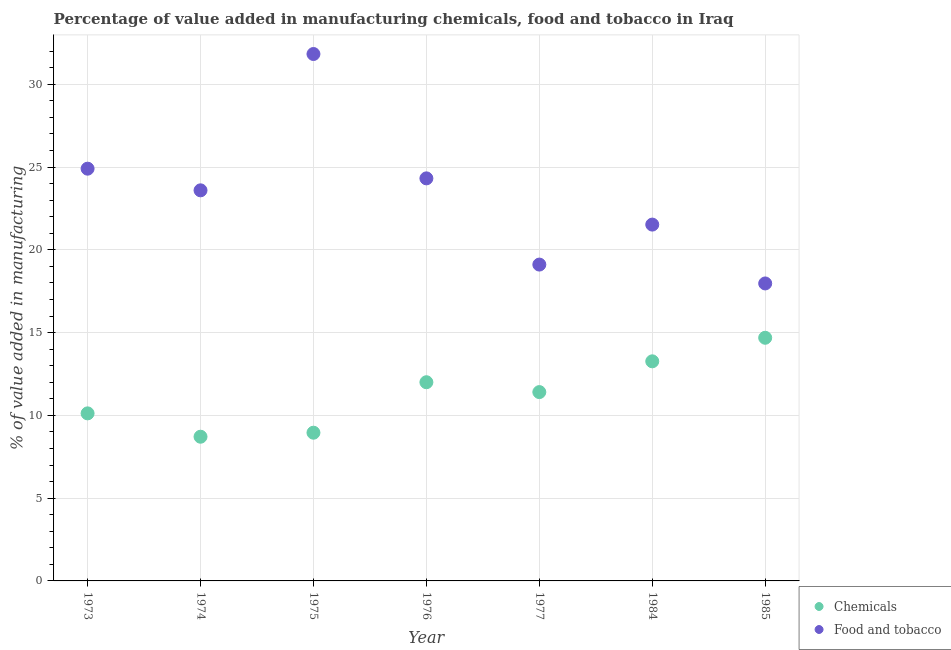Is the number of dotlines equal to the number of legend labels?
Provide a short and direct response. Yes. What is the value added by  manufacturing chemicals in 1974?
Provide a short and direct response. 8.71. Across all years, what is the maximum value added by  manufacturing chemicals?
Provide a short and direct response. 14.69. Across all years, what is the minimum value added by  manufacturing chemicals?
Ensure brevity in your answer.  8.71. In which year was the value added by manufacturing food and tobacco maximum?
Your answer should be compact. 1975. In which year was the value added by manufacturing food and tobacco minimum?
Keep it short and to the point. 1985. What is the total value added by  manufacturing chemicals in the graph?
Ensure brevity in your answer.  79.15. What is the difference between the value added by  manufacturing chemicals in 1974 and that in 1984?
Offer a terse response. -4.56. What is the difference between the value added by manufacturing food and tobacco in 1975 and the value added by  manufacturing chemicals in 1974?
Offer a terse response. 23.12. What is the average value added by  manufacturing chemicals per year?
Provide a short and direct response. 11.31. In the year 1974, what is the difference between the value added by manufacturing food and tobacco and value added by  manufacturing chemicals?
Your answer should be very brief. 14.89. In how many years, is the value added by  manufacturing chemicals greater than 1 %?
Your answer should be very brief. 7. What is the ratio of the value added by manufacturing food and tobacco in 1973 to that in 1975?
Provide a short and direct response. 0.78. What is the difference between the highest and the second highest value added by  manufacturing chemicals?
Ensure brevity in your answer.  1.42. What is the difference between the highest and the lowest value added by manufacturing food and tobacco?
Ensure brevity in your answer.  13.86. In how many years, is the value added by manufacturing food and tobacco greater than the average value added by manufacturing food and tobacco taken over all years?
Ensure brevity in your answer.  4. Does the value added by  manufacturing chemicals monotonically increase over the years?
Your answer should be very brief. No. How many dotlines are there?
Offer a very short reply. 2. Are the values on the major ticks of Y-axis written in scientific E-notation?
Your answer should be compact. No. Does the graph contain grids?
Offer a very short reply. Yes. Where does the legend appear in the graph?
Your response must be concise. Bottom right. How many legend labels are there?
Your response must be concise. 2. What is the title of the graph?
Offer a very short reply. Percentage of value added in manufacturing chemicals, food and tobacco in Iraq. What is the label or title of the X-axis?
Your answer should be very brief. Year. What is the label or title of the Y-axis?
Ensure brevity in your answer.  % of value added in manufacturing. What is the % of value added in manufacturing of Chemicals in 1973?
Ensure brevity in your answer.  10.12. What is the % of value added in manufacturing of Food and tobacco in 1973?
Your answer should be compact. 24.9. What is the % of value added in manufacturing of Chemicals in 1974?
Give a very brief answer. 8.71. What is the % of value added in manufacturing in Food and tobacco in 1974?
Offer a terse response. 23.6. What is the % of value added in manufacturing in Chemicals in 1975?
Give a very brief answer. 8.95. What is the % of value added in manufacturing in Food and tobacco in 1975?
Make the answer very short. 31.83. What is the % of value added in manufacturing in Chemicals in 1976?
Provide a short and direct response. 12. What is the % of value added in manufacturing in Food and tobacco in 1976?
Offer a terse response. 24.32. What is the % of value added in manufacturing of Chemicals in 1977?
Offer a terse response. 11.41. What is the % of value added in manufacturing in Food and tobacco in 1977?
Your answer should be compact. 19.11. What is the % of value added in manufacturing of Chemicals in 1984?
Ensure brevity in your answer.  13.27. What is the % of value added in manufacturing in Food and tobacco in 1984?
Your answer should be compact. 21.53. What is the % of value added in manufacturing of Chemicals in 1985?
Ensure brevity in your answer.  14.69. What is the % of value added in manufacturing of Food and tobacco in 1985?
Your answer should be very brief. 17.97. Across all years, what is the maximum % of value added in manufacturing of Chemicals?
Your answer should be compact. 14.69. Across all years, what is the maximum % of value added in manufacturing in Food and tobacco?
Keep it short and to the point. 31.83. Across all years, what is the minimum % of value added in manufacturing in Chemicals?
Offer a very short reply. 8.71. Across all years, what is the minimum % of value added in manufacturing of Food and tobacco?
Make the answer very short. 17.97. What is the total % of value added in manufacturing in Chemicals in the graph?
Offer a very short reply. 79.15. What is the total % of value added in manufacturing in Food and tobacco in the graph?
Offer a terse response. 163.26. What is the difference between the % of value added in manufacturing of Chemicals in 1973 and that in 1974?
Offer a very short reply. 1.41. What is the difference between the % of value added in manufacturing in Food and tobacco in 1973 and that in 1974?
Offer a very short reply. 1.31. What is the difference between the % of value added in manufacturing in Chemicals in 1973 and that in 1975?
Offer a very short reply. 1.17. What is the difference between the % of value added in manufacturing in Food and tobacco in 1973 and that in 1975?
Keep it short and to the point. -6.93. What is the difference between the % of value added in manufacturing in Chemicals in 1973 and that in 1976?
Make the answer very short. -1.88. What is the difference between the % of value added in manufacturing of Food and tobacco in 1973 and that in 1976?
Your response must be concise. 0.59. What is the difference between the % of value added in manufacturing of Chemicals in 1973 and that in 1977?
Your response must be concise. -1.29. What is the difference between the % of value added in manufacturing of Food and tobacco in 1973 and that in 1977?
Provide a short and direct response. 5.79. What is the difference between the % of value added in manufacturing of Chemicals in 1973 and that in 1984?
Provide a short and direct response. -3.14. What is the difference between the % of value added in manufacturing of Food and tobacco in 1973 and that in 1984?
Offer a very short reply. 3.38. What is the difference between the % of value added in manufacturing in Chemicals in 1973 and that in 1985?
Ensure brevity in your answer.  -4.57. What is the difference between the % of value added in manufacturing of Food and tobacco in 1973 and that in 1985?
Make the answer very short. 6.93. What is the difference between the % of value added in manufacturing of Chemicals in 1974 and that in 1975?
Provide a succinct answer. -0.24. What is the difference between the % of value added in manufacturing in Food and tobacco in 1974 and that in 1975?
Your answer should be very brief. -8.24. What is the difference between the % of value added in manufacturing in Chemicals in 1974 and that in 1976?
Provide a short and direct response. -3.29. What is the difference between the % of value added in manufacturing of Food and tobacco in 1974 and that in 1976?
Provide a succinct answer. -0.72. What is the difference between the % of value added in manufacturing in Chemicals in 1974 and that in 1977?
Offer a terse response. -2.7. What is the difference between the % of value added in manufacturing in Food and tobacco in 1974 and that in 1977?
Your answer should be very brief. 4.49. What is the difference between the % of value added in manufacturing in Chemicals in 1974 and that in 1984?
Offer a terse response. -4.55. What is the difference between the % of value added in manufacturing of Food and tobacco in 1974 and that in 1984?
Your answer should be very brief. 2.07. What is the difference between the % of value added in manufacturing in Chemicals in 1974 and that in 1985?
Give a very brief answer. -5.98. What is the difference between the % of value added in manufacturing of Food and tobacco in 1974 and that in 1985?
Your answer should be very brief. 5.63. What is the difference between the % of value added in manufacturing of Chemicals in 1975 and that in 1976?
Provide a short and direct response. -3.05. What is the difference between the % of value added in manufacturing in Food and tobacco in 1975 and that in 1976?
Offer a terse response. 7.51. What is the difference between the % of value added in manufacturing in Chemicals in 1975 and that in 1977?
Your answer should be compact. -2.45. What is the difference between the % of value added in manufacturing in Food and tobacco in 1975 and that in 1977?
Provide a short and direct response. 12.72. What is the difference between the % of value added in manufacturing in Chemicals in 1975 and that in 1984?
Keep it short and to the point. -4.31. What is the difference between the % of value added in manufacturing in Food and tobacco in 1975 and that in 1984?
Make the answer very short. 10.31. What is the difference between the % of value added in manufacturing in Chemicals in 1975 and that in 1985?
Your answer should be compact. -5.74. What is the difference between the % of value added in manufacturing in Food and tobacco in 1975 and that in 1985?
Your response must be concise. 13.86. What is the difference between the % of value added in manufacturing in Chemicals in 1976 and that in 1977?
Give a very brief answer. 0.6. What is the difference between the % of value added in manufacturing in Food and tobacco in 1976 and that in 1977?
Give a very brief answer. 5.21. What is the difference between the % of value added in manufacturing in Chemicals in 1976 and that in 1984?
Provide a succinct answer. -1.26. What is the difference between the % of value added in manufacturing in Food and tobacco in 1976 and that in 1984?
Ensure brevity in your answer.  2.79. What is the difference between the % of value added in manufacturing of Chemicals in 1976 and that in 1985?
Keep it short and to the point. -2.69. What is the difference between the % of value added in manufacturing of Food and tobacco in 1976 and that in 1985?
Make the answer very short. 6.35. What is the difference between the % of value added in manufacturing in Chemicals in 1977 and that in 1984?
Your response must be concise. -1.86. What is the difference between the % of value added in manufacturing in Food and tobacco in 1977 and that in 1984?
Offer a very short reply. -2.42. What is the difference between the % of value added in manufacturing of Chemicals in 1977 and that in 1985?
Your response must be concise. -3.28. What is the difference between the % of value added in manufacturing in Food and tobacco in 1977 and that in 1985?
Your answer should be very brief. 1.14. What is the difference between the % of value added in manufacturing in Chemicals in 1984 and that in 1985?
Offer a terse response. -1.42. What is the difference between the % of value added in manufacturing in Food and tobacco in 1984 and that in 1985?
Keep it short and to the point. 3.56. What is the difference between the % of value added in manufacturing of Chemicals in 1973 and the % of value added in manufacturing of Food and tobacco in 1974?
Make the answer very short. -13.47. What is the difference between the % of value added in manufacturing in Chemicals in 1973 and the % of value added in manufacturing in Food and tobacco in 1975?
Your answer should be very brief. -21.71. What is the difference between the % of value added in manufacturing of Chemicals in 1973 and the % of value added in manufacturing of Food and tobacco in 1976?
Provide a succinct answer. -14.2. What is the difference between the % of value added in manufacturing in Chemicals in 1973 and the % of value added in manufacturing in Food and tobacco in 1977?
Give a very brief answer. -8.99. What is the difference between the % of value added in manufacturing of Chemicals in 1973 and the % of value added in manufacturing of Food and tobacco in 1984?
Your response must be concise. -11.4. What is the difference between the % of value added in manufacturing in Chemicals in 1973 and the % of value added in manufacturing in Food and tobacco in 1985?
Make the answer very short. -7.85. What is the difference between the % of value added in manufacturing of Chemicals in 1974 and the % of value added in manufacturing of Food and tobacco in 1975?
Your answer should be compact. -23.12. What is the difference between the % of value added in manufacturing of Chemicals in 1974 and the % of value added in manufacturing of Food and tobacco in 1976?
Offer a terse response. -15.61. What is the difference between the % of value added in manufacturing in Chemicals in 1974 and the % of value added in manufacturing in Food and tobacco in 1977?
Ensure brevity in your answer.  -10.4. What is the difference between the % of value added in manufacturing of Chemicals in 1974 and the % of value added in manufacturing of Food and tobacco in 1984?
Offer a very short reply. -12.82. What is the difference between the % of value added in manufacturing in Chemicals in 1974 and the % of value added in manufacturing in Food and tobacco in 1985?
Your answer should be compact. -9.26. What is the difference between the % of value added in manufacturing of Chemicals in 1975 and the % of value added in manufacturing of Food and tobacco in 1976?
Ensure brevity in your answer.  -15.37. What is the difference between the % of value added in manufacturing of Chemicals in 1975 and the % of value added in manufacturing of Food and tobacco in 1977?
Ensure brevity in your answer.  -10.16. What is the difference between the % of value added in manufacturing of Chemicals in 1975 and the % of value added in manufacturing of Food and tobacco in 1984?
Offer a terse response. -12.57. What is the difference between the % of value added in manufacturing in Chemicals in 1975 and the % of value added in manufacturing in Food and tobacco in 1985?
Your response must be concise. -9.02. What is the difference between the % of value added in manufacturing of Chemicals in 1976 and the % of value added in manufacturing of Food and tobacco in 1977?
Ensure brevity in your answer.  -7.11. What is the difference between the % of value added in manufacturing in Chemicals in 1976 and the % of value added in manufacturing in Food and tobacco in 1984?
Make the answer very short. -9.52. What is the difference between the % of value added in manufacturing in Chemicals in 1976 and the % of value added in manufacturing in Food and tobacco in 1985?
Your answer should be very brief. -5.97. What is the difference between the % of value added in manufacturing in Chemicals in 1977 and the % of value added in manufacturing in Food and tobacco in 1984?
Your answer should be compact. -10.12. What is the difference between the % of value added in manufacturing of Chemicals in 1977 and the % of value added in manufacturing of Food and tobacco in 1985?
Offer a very short reply. -6.56. What is the difference between the % of value added in manufacturing in Chemicals in 1984 and the % of value added in manufacturing in Food and tobacco in 1985?
Provide a short and direct response. -4.71. What is the average % of value added in manufacturing of Chemicals per year?
Your answer should be compact. 11.31. What is the average % of value added in manufacturing of Food and tobacco per year?
Offer a very short reply. 23.32. In the year 1973, what is the difference between the % of value added in manufacturing in Chemicals and % of value added in manufacturing in Food and tobacco?
Ensure brevity in your answer.  -14.78. In the year 1974, what is the difference between the % of value added in manufacturing of Chemicals and % of value added in manufacturing of Food and tobacco?
Your answer should be compact. -14.89. In the year 1975, what is the difference between the % of value added in manufacturing in Chemicals and % of value added in manufacturing in Food and tobacco?
Give a very brief answer. -22.88. In the year 1976, what is the difference between the % of value added in manufacturing in Chemicals and % of value added in manufacturing in Food and tobacco?
Offer a very short reply. -12.32. In the year 1977, what is the difference between the % of value added in manufacturing in Chemicals and % of value added in manufacturing in Food and tobacco?
Make the answer very short. -7.7. In the year 1984, what is the difference between the % of value added in manufacturing of Chemicals and % of value added in manufacturing of Food and tobacco?
Provide a short and direct response. -8.26. In the year 1985, what is the difference between the % of value added in manufacturing of Chemicals and % of value added in manufacturing of Food and tobacco?
Offer a very short reply. -3.28. What is the ratio of the % of value added in manufacturing in Chemicals in 1973 to that in 1974?
Provide a succinct answer. 1.16. What is the ratio of the % of value added in manufacturing in Food and tobacco in 1973 to that in 1974?
Make the answer very short. 1.06. What is the ratio of the % of value added in manufacturing of Chemicals in 1973 to that in 1975?
Ensure brevity in your answer.  1.13. What is the ratio of the % of value added in manufacturing of Food and tobacco in 1973 to that in 1975?
Ensure brevity in your answer.  0.78. What is the ratio of the % of value added in manufacturing in Chemicals in 1973 to that in 1976?
Ensure brevity in your answer.  0.84. What is the ratio of the % of value added in manufacturing of Food and tobacco in 1973 to that in 1976?
Your response must be concise. 1.02. What is the ratio of the % of value added in manufacturing of Chemicals in 1973 to that in 1977?
Offer a terse response. 0.89. What is the ratio of the % of value added in manufacturing of Food and tobacco in 1973 to that in 1977?
Give a very brief answer. 1.3. What is the ratio of the % of value added in manufacturing in Chemicals in 1973 to that in 1984?
Your answer should be very brief. 0.76. What is the ratio of the % of value added in manufacturing in Food and tobacco in 1973 to that in 1984?
Your response must be concise. 1.16. What is the ratio of the % of value added in manufacturing of Chemicals in 1973 to that in 1985?
Your answer should be very brief. 0.69. What is the ratio of the % of value added in manufacturing in Food and tobacco in 1973 to that in 1985?
Your answer should be very brief. 1.39. What is the ratio of the % of value added in manufacturing of Chemicals in 1974 to that in 1975?
Offer a very short reply. 0.97. What is the ratio of the % of value added in manufacturing in Food and tobacco in 1974 to that in 1975?
Your answer should be compact. 0.74. What is the ratio of the % of value added in manufacturing of Chemicals in 1974 to that in 1976?
Your response must be concise. 0.73. What is the ratio of the % of value added in manufacturing in Food and tobacco in 1974 to that in 1976?
Provide a succinct answer. 0.97. What is the ratio of the % of value added in manufacturing of Chemicals in 1974 to that in 1977?
Your response must be concise. 0.76. What is the ratio of the % of value added in manufacturing in Food and tobacco in 1974 to that in 1977?
Your answer should be very brief. 1.23. What is the ratio of the % of value added in manufacturing of Chemicals in 1974 to that in 1984?
Offer a terse response. 0.66. What is the ratio of the % of value added in manufacturing of Food and tobacco in 1974 to that in 1984?
Provide a short and direct response. 1.1. What is the ratio of the % of value added in manufacturing of Chemicals in 1974 to that in 1985?
Ensure brevity in your answer.  0.59. What is the ratio of the % of value added in manufacturing in Food and tobacco in 1974 to that in 1985?
Your response must be concise. 1.31. What is the ratio of the % of value added in manufacturing in Chemicals in 1975 to that in 1976?
Provide a short and direct response. 0.75. What is the ratio of the % of value added in manufacturing of Food and tobacco in 1975 to that in 1976?
Offer a terse response. 1.31. What is the ratio of the % of value added in manufacturing of Chemicals in 1975 to that in 1977?
Provide a short and direct response. 0.78. What is the ratio of the % of value added in manufacturing in Food and tobacco in 1975 to that in 1977?
Your response must be concise. 1.67. What is the ratio of the % of value added in manufacturing in Chemicals in 1975 to that in 1984?
Keep it short and to the point. 0.68. What is the ratio of the % of value added in manufacturing of Food and tobacco in 1975 to that in 1984?
Your answer should be very brief. 1.48. What is the ratio of the % of value added in manufacturing of Chemicals in 1975 to that in 1985?
Offer a very short reply. 0.61. What is the ratio of the % of value added in manufacturing of Food and tobacco in 1975 to that in 1985?
Give a very brief answer. 1.77. What is the ratio of the % of value added in manufacturing in Chemicals in 1976 to that in 1977?
Give a very brief answer. 1.05. What is the ratio of the % of value added in manufacturing of Food and tobacco in 1976 to that in 1977?
Ensure brevity in your answer.  1.27. What is the ratio of the % of value added in manufacturing in Chemicals in 1976 to that in 1984?
Make the answer very short. 0.9. What is the ratio of the % of value added in manufacturing of Food and tobacco in 1976 to that in 1984?
Provide a short and direct response. 1.13. What is the ratio of the % of value added in manufacturing of Chemicals in 1976 to that in 1985?
Keep it short and to the point. 0.82. What is the ratio of the % of value added in manufacturing of Food and tobacco in 1976 to that in 1985?
Give a very brief answer. 1.35. What is the ratio of the % of value added in manufacturing in Chemicals in 1977 to that in 1984?
Your response must be concise. 0.86. What is the ratio of the % of value added in manufacturing of Food and tobacco in 1977 to that in 1984?
Ensure brevity in your answer.  0.89. What is the ratio of the % of value added in manufacturing of Chemicals in 1977 to that in 1985?
Ensure brevity in your answer.  0.78. What is the ratio of the % of value added in manufacturing in Food and tobacco in 1977 to that in 1985?
Ensure brevity in your answer.  1.06. What is the ratio of the % of value added in manufacturing in Chemicals in 1984 to that in 1985?
Offer a terse response. 0.9. What is the ratio of the % of value added in manufacturing in Food and tobacco in 1984 to that in 1985?
Offer a very short reply. 1.2. What is the difference between the highest and the second highest % of value added in manufacturing of Chemicals?
Offer a terse response. 1.42. What is the difference between the highest and the second highest % of value added in manufacturing in Food and tobacco?
Make the answer very short. 6.93. What is the difference between the highest and the lowest % of value added in manufacturing in Chemicals?
Give a very brief answer. 5.98. What is the difference between the highest and the lowest % of value added in manufacturing of Food and tobacco?
Your response must be concise. 13.86. 